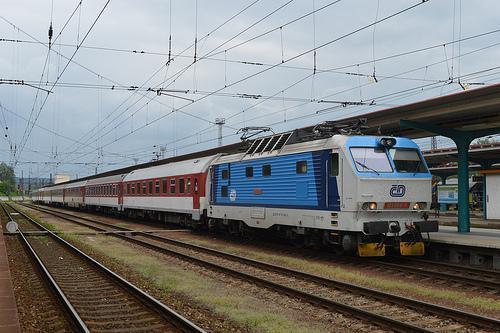How many trains are in the picture?
Give a very brief answer. 1. 